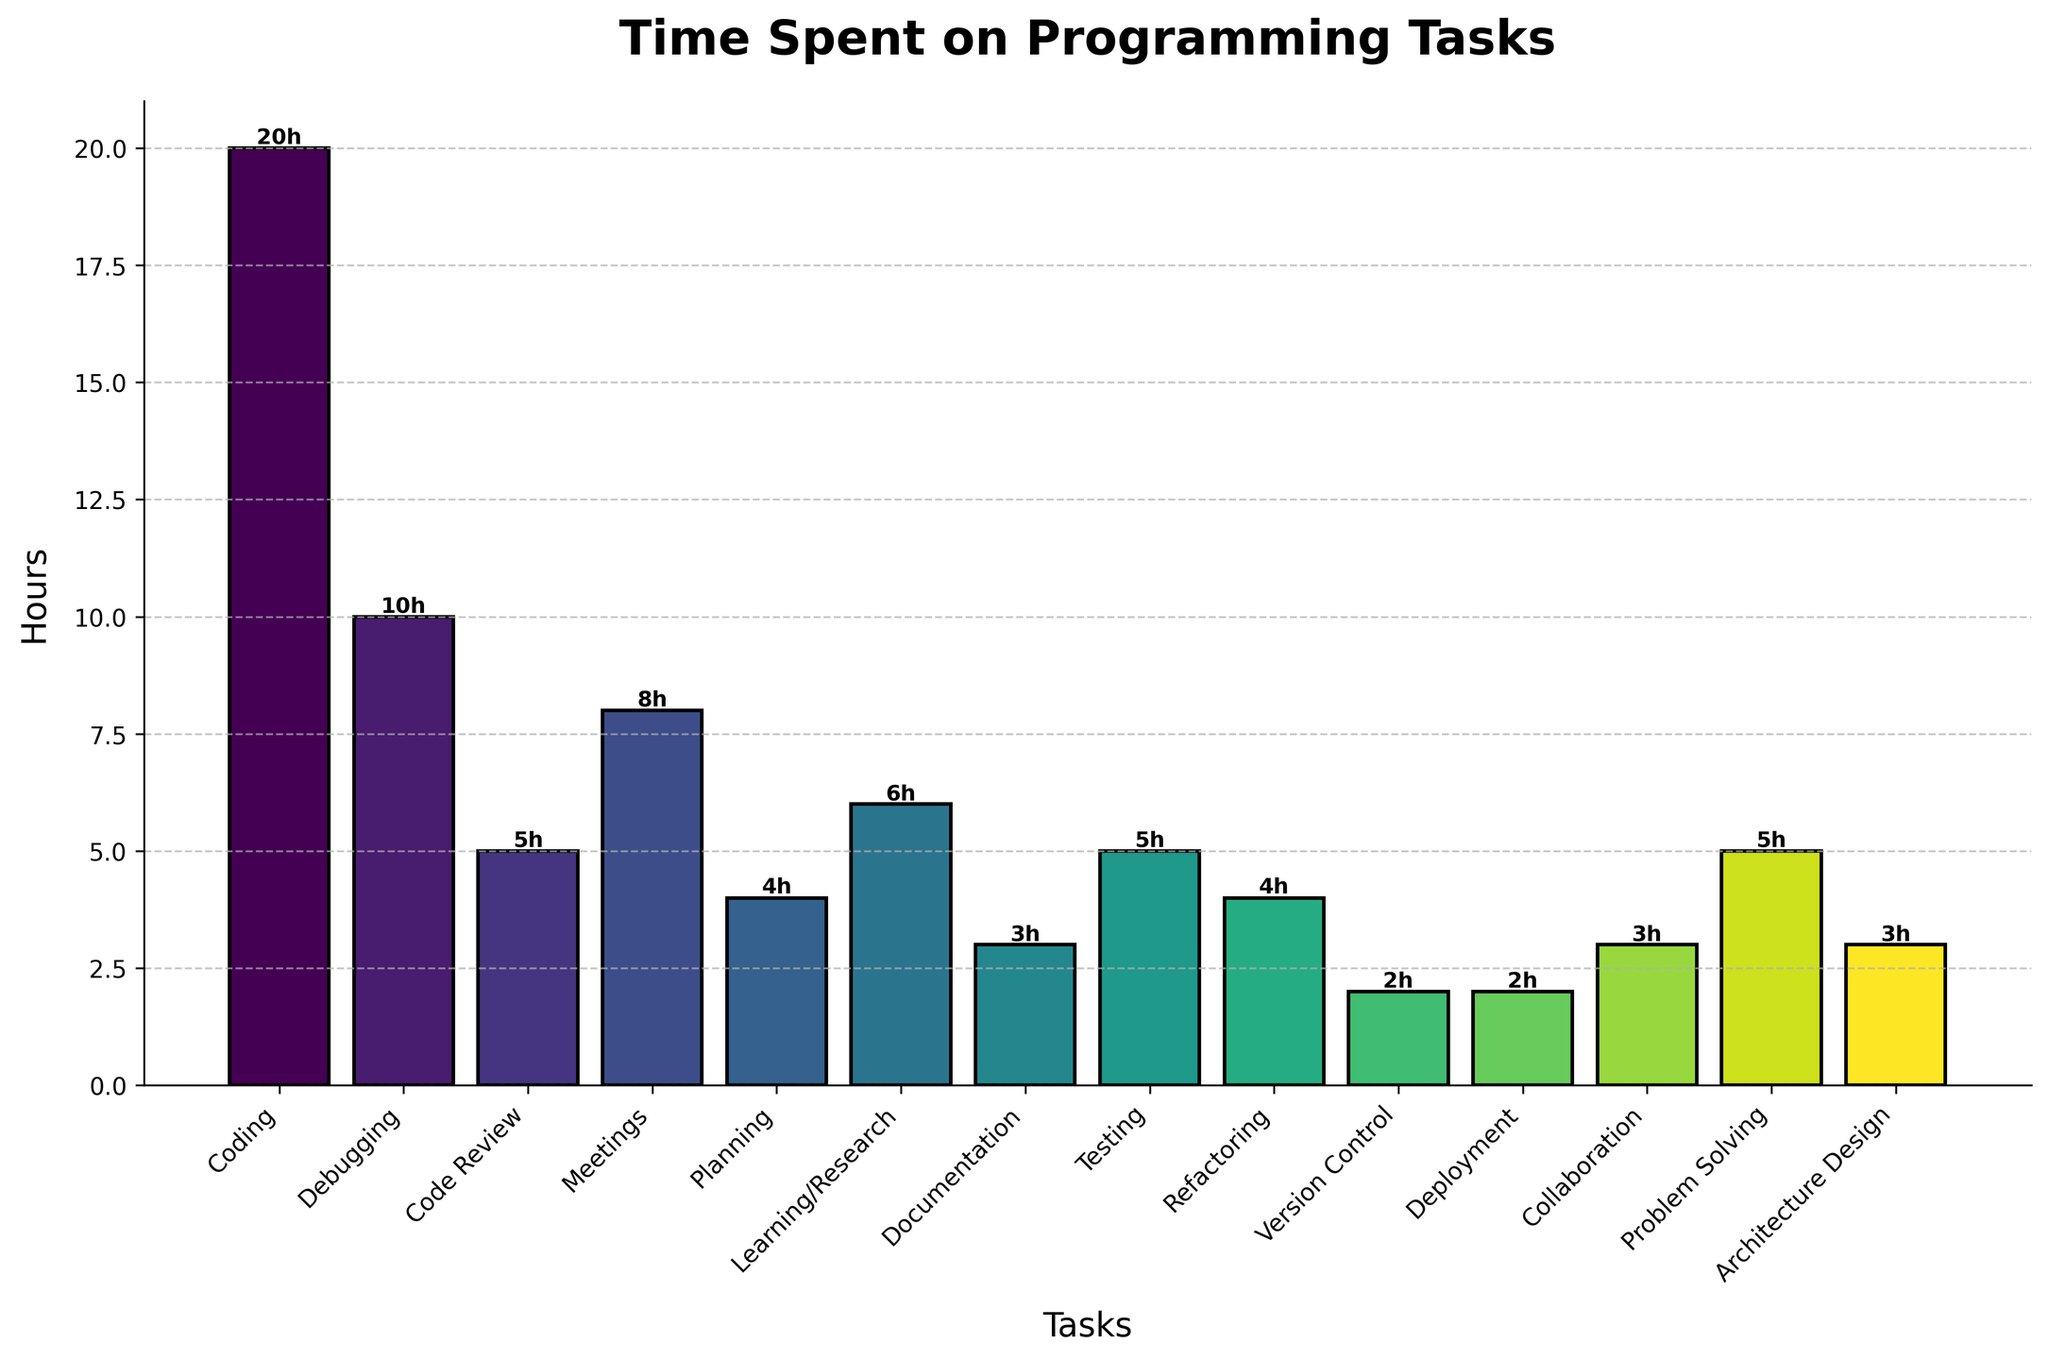Which task takes up the most hours? By glancing at the bar chart, the task with the tallest bar represents the task that takes the most hours. Here, 'Coding' has the tallest bar.
Answer: Coding How many total hours are spent on meetings, planning, and code review combined? First, identify the hours spent on each task: Meetings (8 hours), Planning (4 hours), Code Review (5 hours). Add them together: 8 + 4 + 5 = 17 hours.
Answer: 17 Are more hours spent on debugging or on testing? Compare the heights of the bars for 'Debugging' (10 hours) and 'Testing' (5 hours). The 'Debugging' bar is taller.
Answer: Debugging What is the difference in hours between coding and version control? Check the hours for both tasks: Coding (20 hours) and Version Control (2 hours). Calculate the difference: 20 - 2 = 18 hours.
Answer: 18 Which tasks have 5 hours allocated to them? Look for the bars that are labeled with '5h'. The tasks are 'Code Review,' 'Testing,' and 'Problem Solving.'
Answer: Code Review, Testing, Problem Solving What's the total time spent on tasks related to development (coding, debugging, refactoring)? Identify the hours spent on each task: Coding (20 hours), Debugging (10 hours), Refactoring (4 hours). Add them together: 20 + 10 + 4 = 34 hours.
Answer: 34 Do any tasks have the same amount of hours, and if so, which? Look for bars that have the same height and label. 'Testing' and 'Problem Solving' each have 5 hours, 'Documentation' and 'Architecture Design' each have 3 hours.
Answer: Testing and Problem Solving; Documentation and Architecture Design What's the average time spent across all the tasks? Sum the hours for all tasks and divide by the total number of tasks (14). The total is 20 + 10 + 5 + 8 + 4 + 6 + 3 + 5 + 4 + 2 + 2 + 3 + 5 + 3 = 80 hours. Average = 80 / 14 ≈ 5.71 hours.
Answer: 5.71 Which task has the least amount of time allocated to it? The shortest bar represents the task with the least time. Both 'Version Control' and 'Deployment' have the shortest bars with 2 hours each.
Answer: Version Control, Deployment 